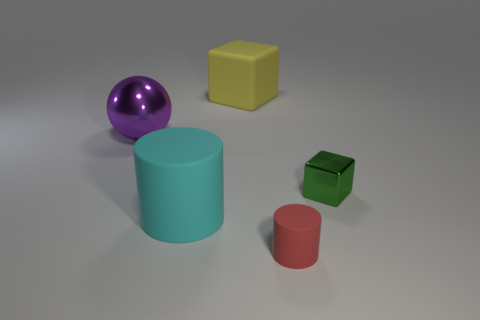Subtract all yellow blocks. Subtract all blue balls. How many blocks are left? 1 Add 1 yellow things. How many objects exist? 6 Subtract all cylinders. How many objects are left? 3 Add 3 tiny metal things. How many tiny metal things are left? 4 Add 5 matte cubes. How many matte cubes exist? 6 Subtract 0 cyan cubes. How many objects are left? 5 Subtract all purple metal objects. Subtract all big rubber cubes. How many objects are left? 3 